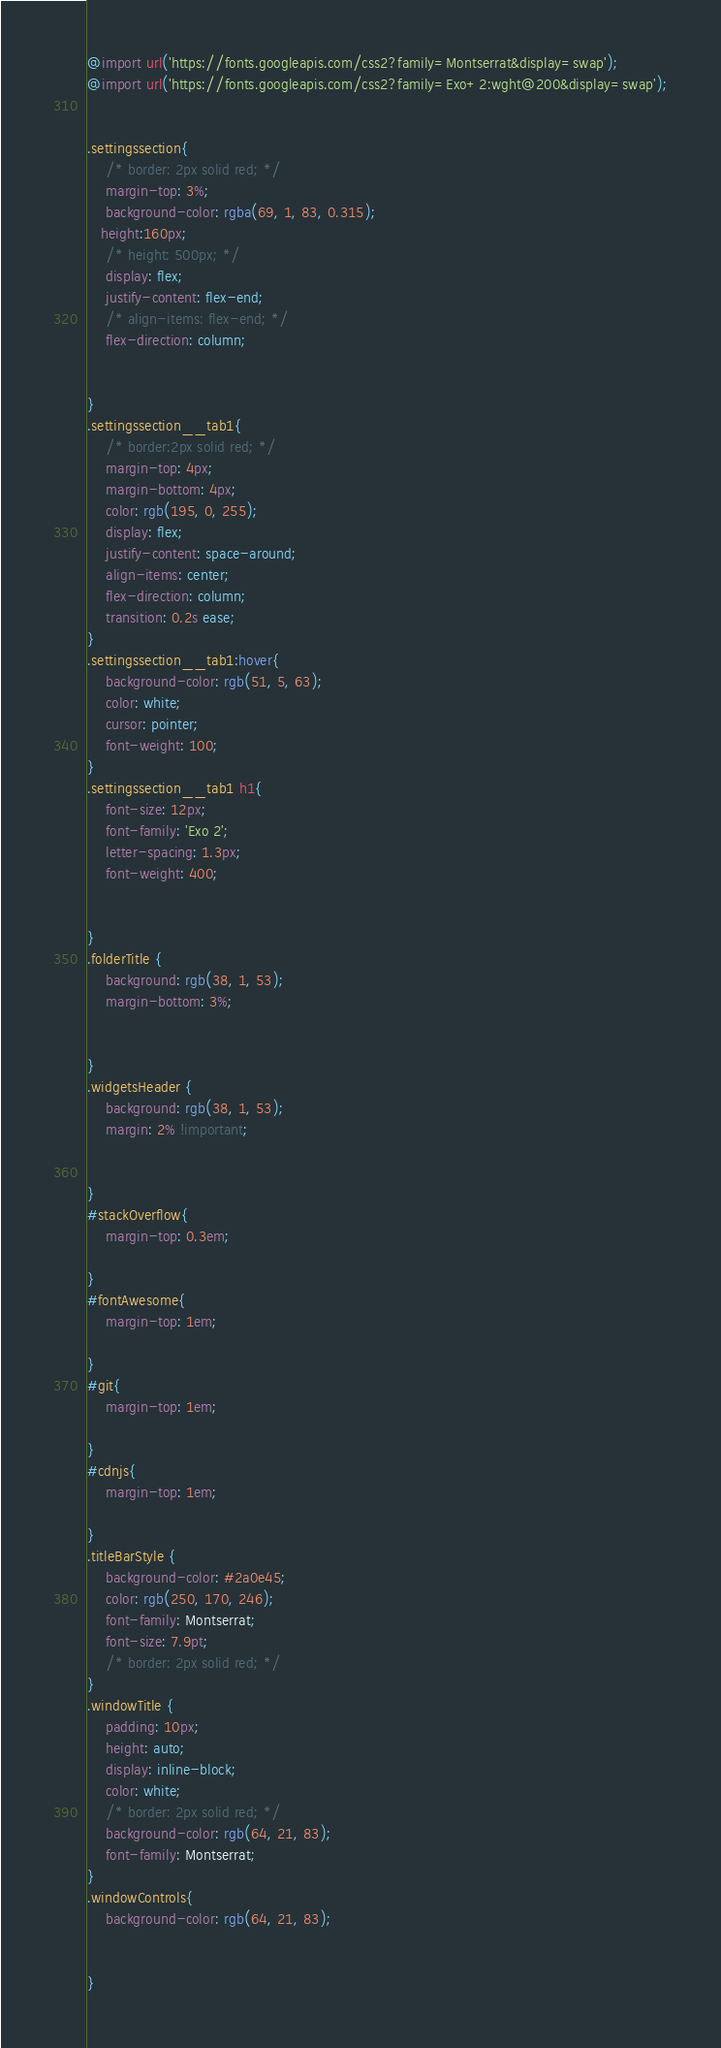Convert code to text. <code><loc_0><loc_0><loc_500><loc_500><_CSS_>@import url('https://fonts.googleapis.com/css2?family=Montserrat&display=swap');
@import url('https://fonts.googleapis.com/css2?family=Exo+2:wght@200&display=swap');


.settingssection{
    /* border: 2px solid red; */
    margin-top: 3%;
    background-color: rgba(69, 1, 83, 0.315);
   height:160px;
    /* height: 500px; */
    display: flex;
    justify-content: flex-end;
    /* align-items: flex-end; */
    flex-direction: column;
 

}
.settingssection__tab1{
    /* border:2px solid red; */
    margin-top: 4px;
    margin-bottom: 4px;
    color: rgb(195, 0, 255);
    display: flex;
    justify-content: space-around;
    align-items: center;
    flex-direction: column;
    transition: 0.2s ease;
}
.settingssection__tab1:hover{
    background-color: rgb(51, 5, 63);
    color: white;
    cursor: pointer;
    font-weight: 100;
}
.settingssection__tab1 h1{
    font-size: 12px;
    font-family: 'Exo 2';
    letter-spacing: 1.3px;
    font-weight: 400;
    

}
.folderTitle {
    background: rgb(38, 1, 53);
    margin-bottom: 3%;
 

}
.widgetsHeader {
    background: rgb(38, 1, 53);
    margin: 2% !important;

    
}
#stackOverflow{
    margin-top: 0.3em;

}
#fontAwesome{
    margin-top: 1em;

}
#git{
    margin-top: 1em;

}
#cdnjs{
    margin-top: 1em;

}
.titleBarStyle {
    background-color: #2a0e45;
    color: rgb(250, 170, 246);
    font-family: Montserrat;
    font-size: 7.9pt;
    /* border: 2px solid red; */
}
.windowTitle {
    padding: 10px;
    height: auto;
    display: inline-block;
    color: white;
    /* border: 2px solid red; */
    background-color: rgb(64, 21, 83);
    font-family: Montserrat;
}
.windowControls{
    background-color: rgb(64, 21, 83);


}
</code> 